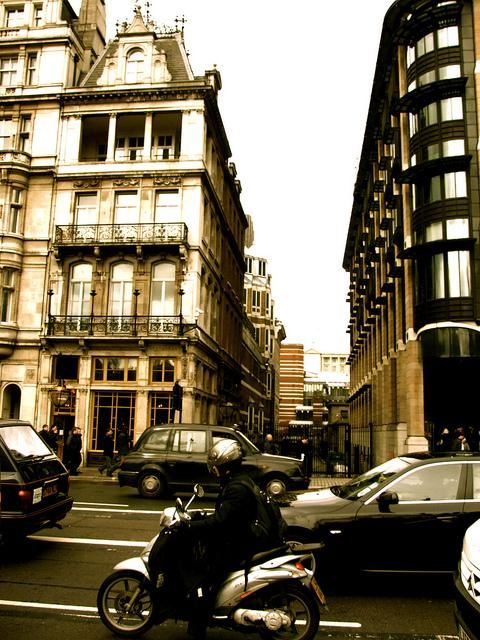How many motorcycles do you see?

Choices:
A) four
B) three
C) six
D) one one 